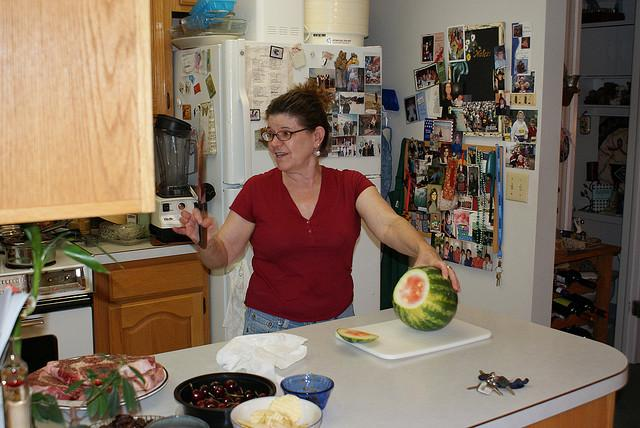What is the appliance next to the refrigerator?

Choices:
A) tea pot
B) coffee maker
C) blender
D) hand mixer blender 